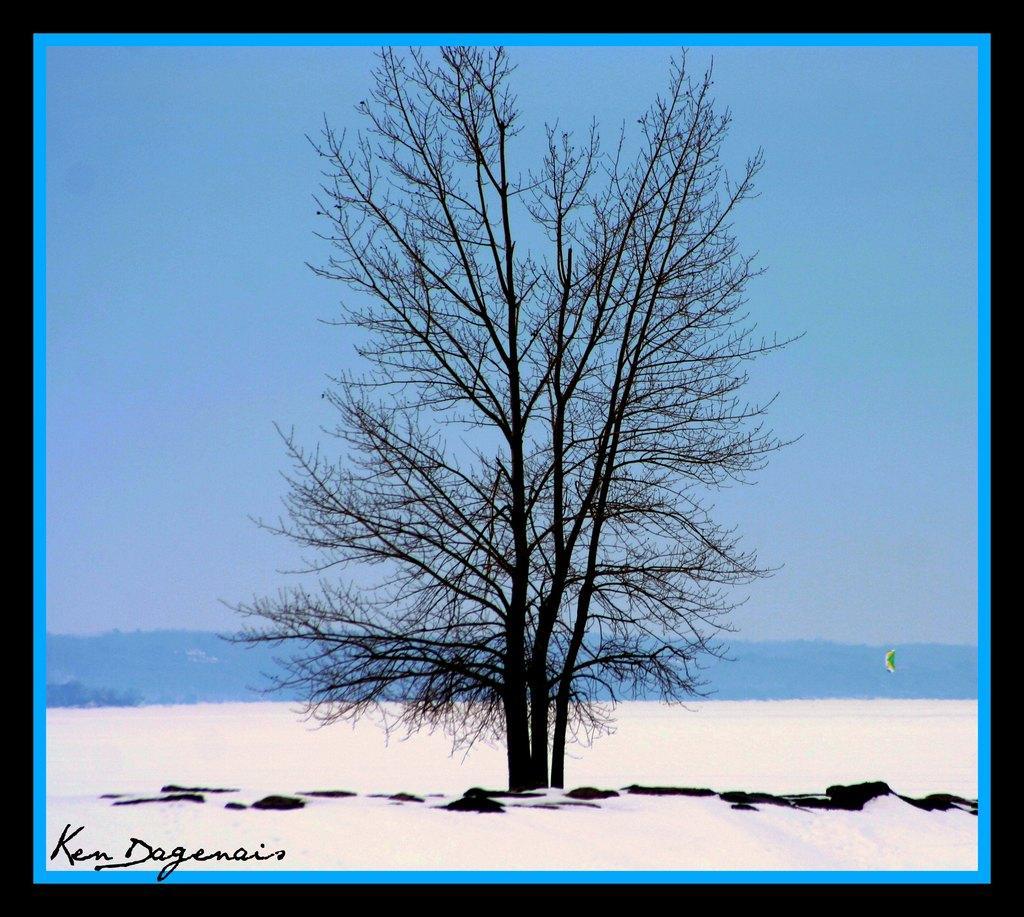How would you summarize this image in a sentence or two? In the middle of the picture, we see a tree. At the bottom, we see the sand. In the background, we see the tree or water. At the top, we see the sky, which is blue in color. This picture might be a photo frame or an edited image. 